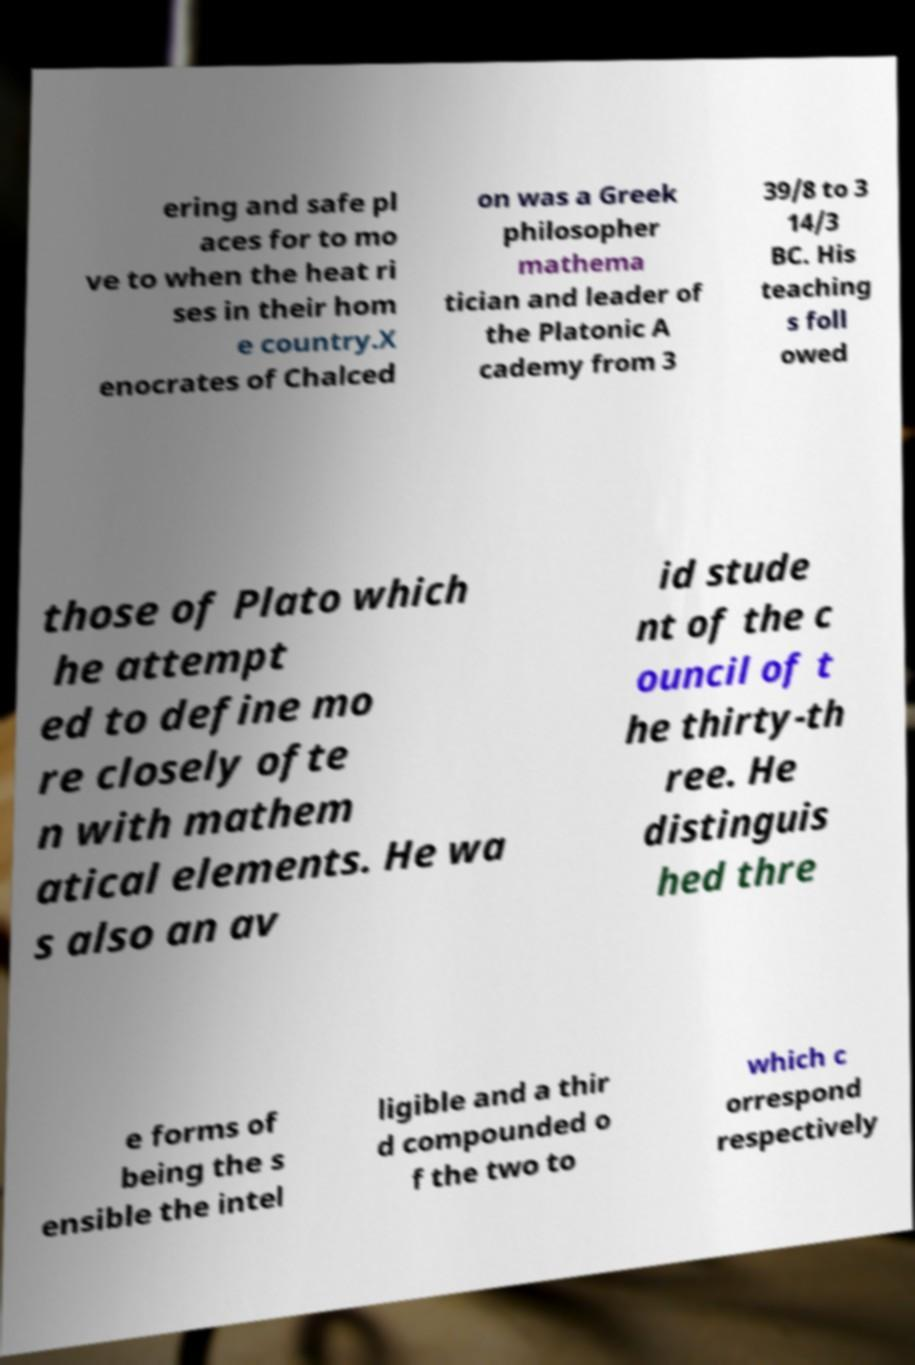There's text embedded in this image that I need extracted. Can you transcribe it verbatim? ering and safe pl aces for to mo ve to when the heat ri ses in their hom e country.X enocrates of Chalced on was a Greek philosopher mathema tician and leader of the Platonic A cademy from 3 39/8 to 3 14/3 BC. His teaching s foll owed those of Plato which he attempt ed to define mo re closely ofte n with mathem atical elements. He wa s also an av id stude nt of the c ouncil of t he thirty-th ree. He distinguis hed thre e forms of being the s ensible the intel ligible and a thir d compounded o f the two to which c orrespond respectively 